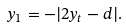Convert formula to latex. <formula><loc_0><loc_0><loc_500><loc_500>y _ { 1 } = - | 2 y _ { t } - d | .</formula> 